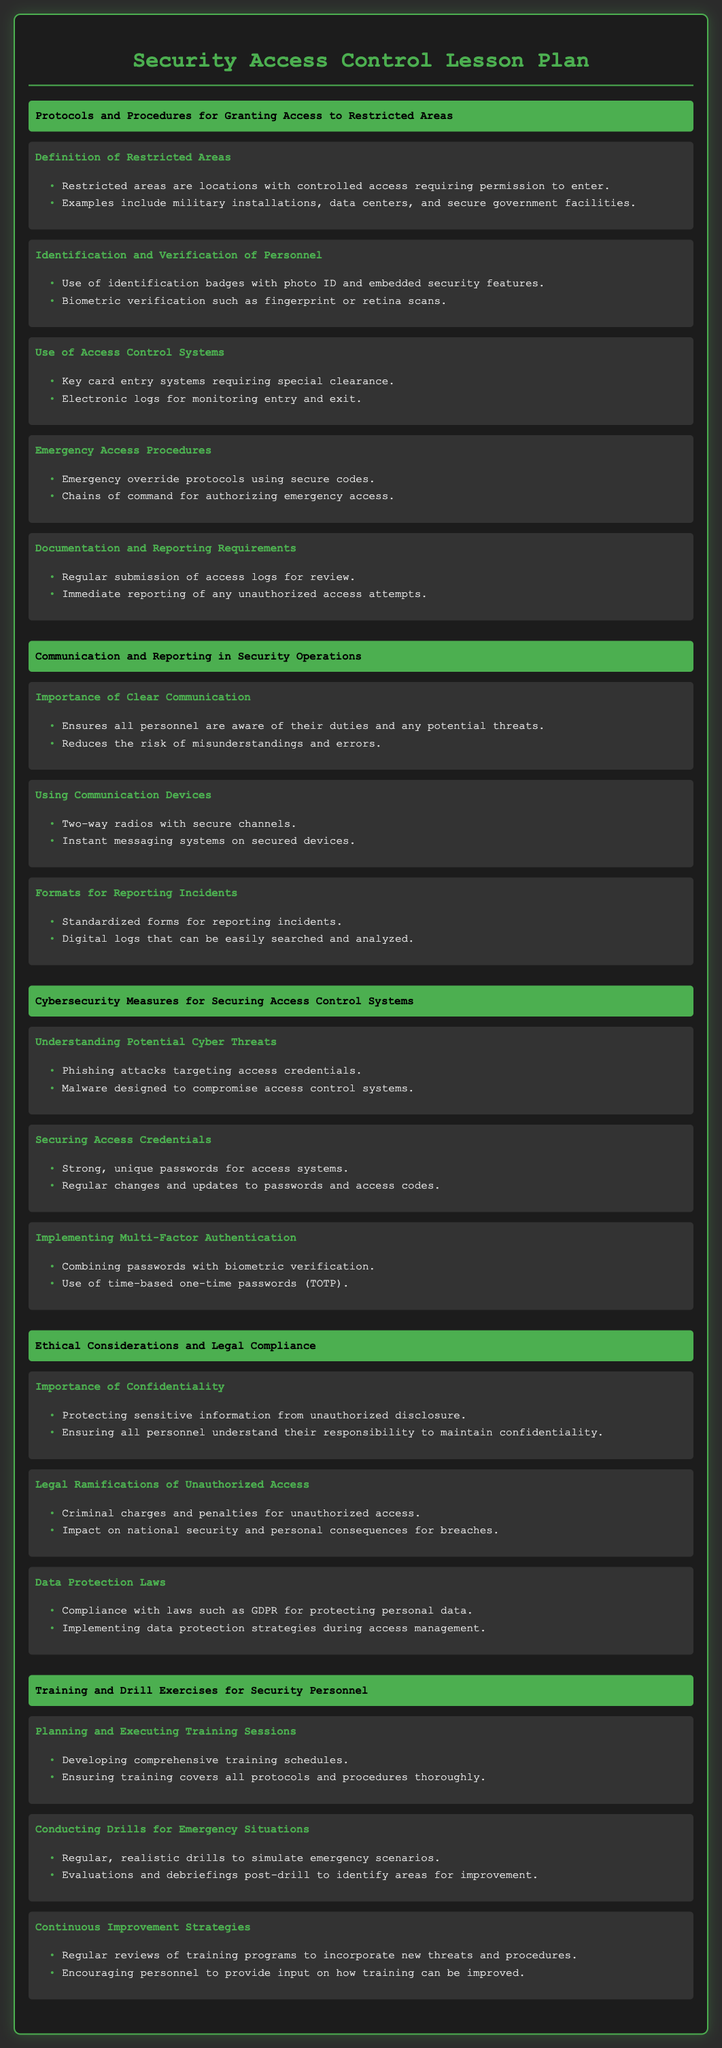what are restricted areas? Restricted areas are locations with controlled access requiring permission to enter, such as military installations and data centers.
Answer: locations with controlled access what is used for identification and verification of personnel? Identification and verification of personnel involve using identification badges with photo ID and embedded security features, as well as biometric verification like fingerprint scans.
Answer: identification badges and biometric verification what is an example of an emergency access procedure? Emergency access procedures include emergency override protocols using secure codes and chains of command for authorizing emergency access.
Answer: emergency override protocols what is the importance of clear communication? Clear communication ensures all personnel are aware of their duties and any potential threats while reducing the risk of misunderstandings and errors.
Answer: ensures awareness and reduces errors what does implementing multi-factor authentication combine? Implementing multi-factor authentication combines passwords with biometric verification, ensuring added security to access control systems.
Answer: passwords and biometric verification what legal ramification does unauthorized access have? Unauthorized access can lead to criminal charges and penalties, impacting national security and resulting in personal consequences for breaches.
Answer: criminal charges and penalties what should training sessions achieve? Training sessions should develop comprehensive training schedules that cover all protocols and procedures thoroughly, ensuring security personnel are well prepared.
Answer: develop comprehensive training schedules what are the types of communication devices mentioned? The types of communication devices include two-way radios with secure channels and instant messaging systems on secured devices.
Answer: two-way radios and instant messaging systems what is the goal of conducting drills for emergency situations? The goal of conducting drills for emergency situations is to simulate realistic emergencies and evaluate personnel performance, identifying areas for improvement.
Answer: simulate realistic emergencies what should be regularly reviewed for improvement? Regular reviews of training programs are necessary to incorporate new threats and procedures while encouraging personnel to provide input on training improvements.
Answer: training programs 